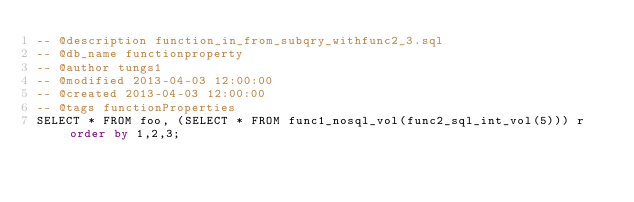<code> <loc_0><loc_0><loc_500><loc_500><_SQL_>-- @description function_in_from_subqry_withfunc2_3.sql
-- @db_name functionproperty
-- @author tungs1
-- @modified 2013-04-03 12:00:00
-- @created 2013-04-03 12:00:00
-- @tags functionProperties 
SELECT * FROM foo, (SELECT * FROM func1_nosql_vol(func2_sql_int_vol(5))) r order by 1,2,3; 
</code> 